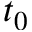Convert formula to latex. <formula><loc_0><loc_0><loc_500><loc_500>t _ { 0 }</formula> 